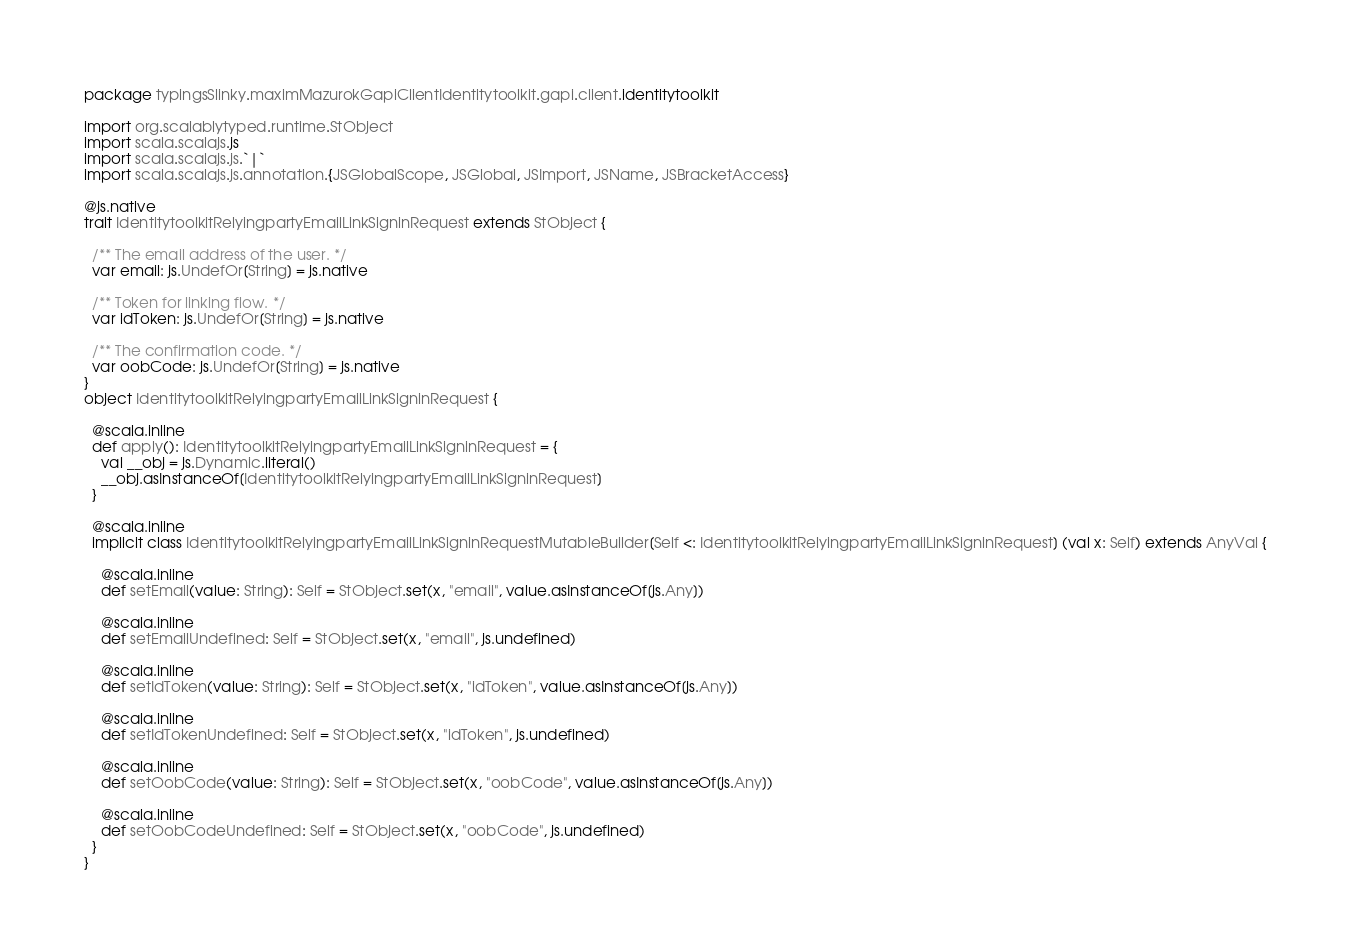Convert code to text. <code><loc_0><loc_0><loc_500><loc_500><_Scala_>package typingsSlinky.maximMazurokGapiClientIdentitytoolkit.gapi.client.identitytoolkit

import org.scalablytyped.runtime.StObject
import scala.scalajs.js
import scala.scalajs.js.`|`
import scala.scalajs.js.annotation.{JSGlobalScope, JSGlobal, JSImport, JSName, JSBracketAccess}

@js.native
trait IdentitytoolkitRelyingpartyEmailLinkSigninRequest extends StObject {
  
  /** The email address of the user. */
  var email: js.UndefOr[String] = js.native
  
  /** Token for linking flow. */
  var idToken: js.UndefOr[String] = js.native
  
  /** The confirmation code. */
  var oobCode: js.UndefOr[String] = js.native
}
object IdentitytoolkitRelyingpartyEmailLinkSigninRequest {
  
  @scala.inline
  def apply(): IdentitytoolkitRelyingpartyEmailLinkSigninRequest = {
    val __obj = js.Dynamic.literal()
    __obj.asInstanceOf[IdentitytoolkitRelyingpartyEmailLinkSigninRequest]
  }
  
  @scala.inline
  implicit class IdentitytoolkitRelyingpartyEmailLinkSigninRequestMutableBuilder[Self <: IdentitytoolkitRelyingpartyEmailLinkSigninRequest] (val x: Self) extends AnyVal {
    
    @scala.inline
    def setEmail(value: String): Self = StObject.set(x, "email", value.asInstanceOf[js.Any])
    
    @scala.inline
    def setEmailUndefined: Self = StObject.set(x, "email", js.undefined)
    
    @scala.inline
    def setIdToken(value: String): Self = StObject.set(x, "idToken", value.asInstanceOf[js.Any])
    
    @scala.inline
    def setIdTokenUndefined: Self = StObject.set(x, "idToken", js.undefined)
    
    @scala.inline
    def setOobCode(value: String): Self = StObject.set(x, "oobCode", value.asInstanceOf[js.Any])
    
    @scala.inline
    def setOobCodeUndefined: Self = StObject.set(x, "oobCode", js.undefined)
  }
}
</code> 